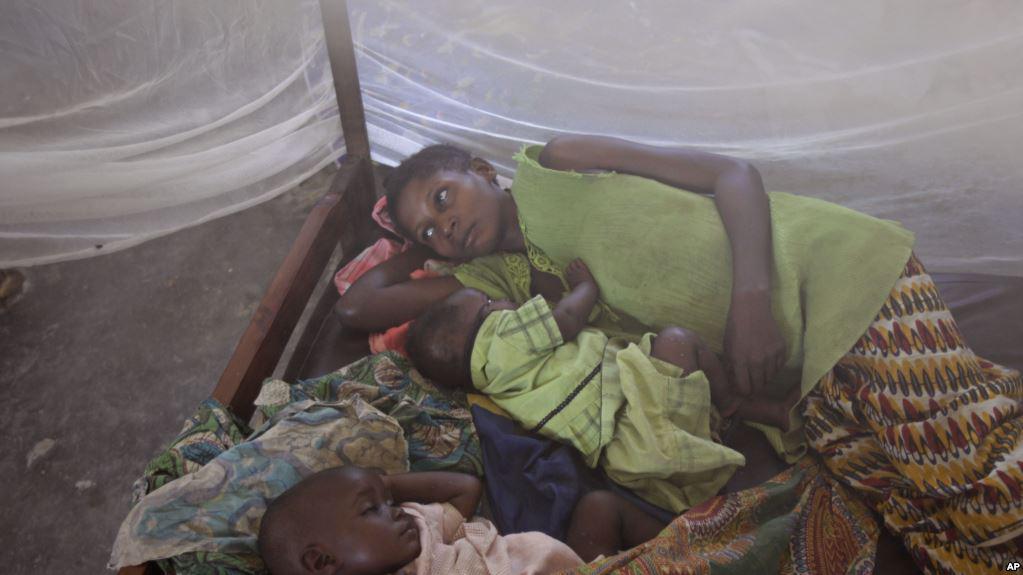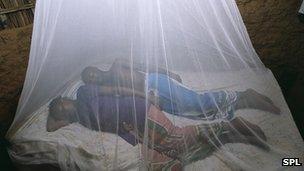The first image is the image on the left, the second image is the image on the right. For the images displayed, is the sentence "An image includes a young baby sleeping under a protective net." factually correct? Answer yes or no. Yes. 